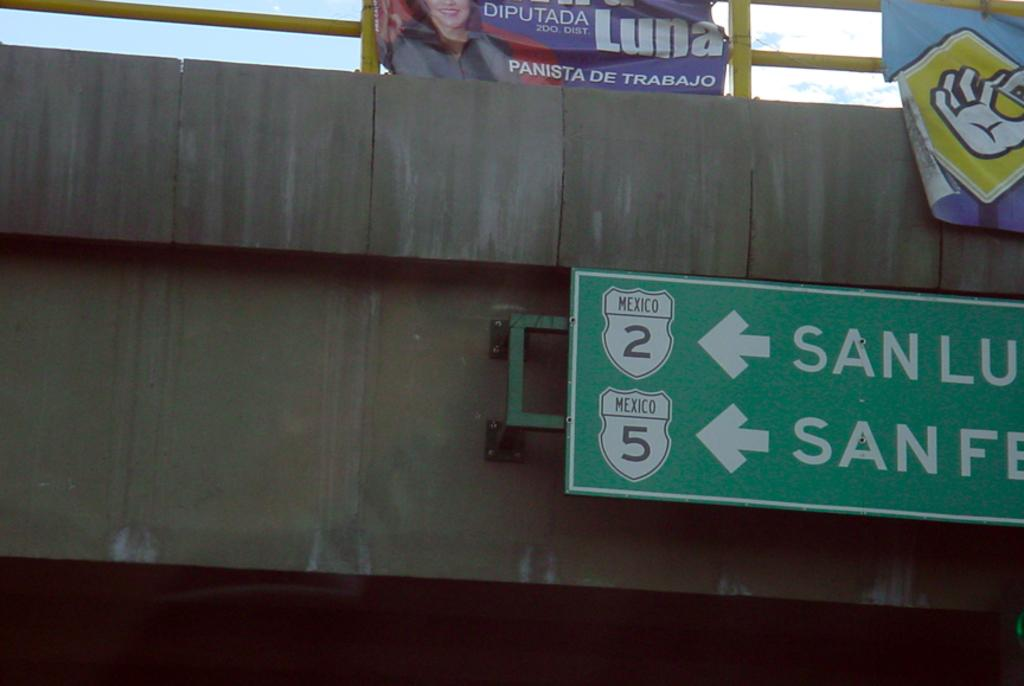<image>
Describe the image concisely. A green sign points the way to Mexico Route 2 and Mexico Route 5 